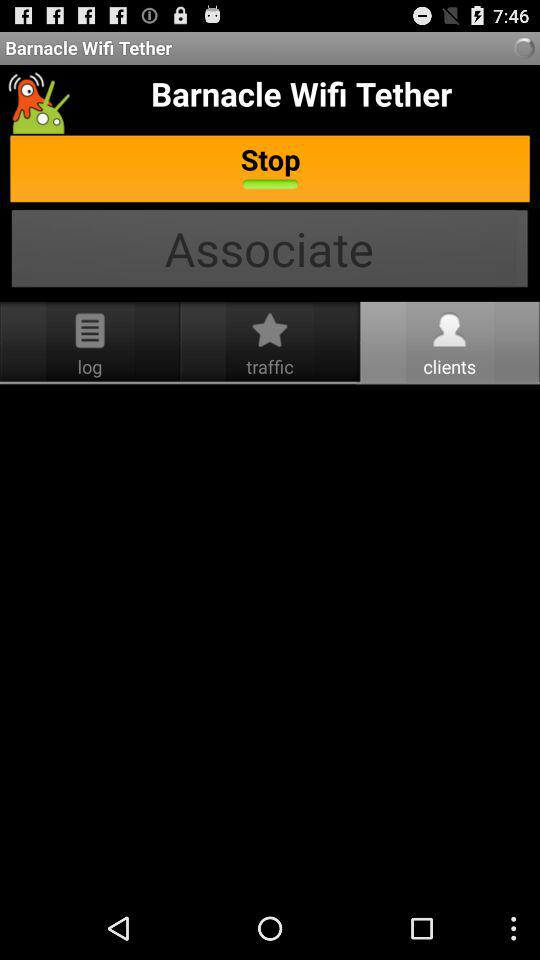What is written in the log?
When the provided information is insufficient, respond with <no answer>. <no answer> 